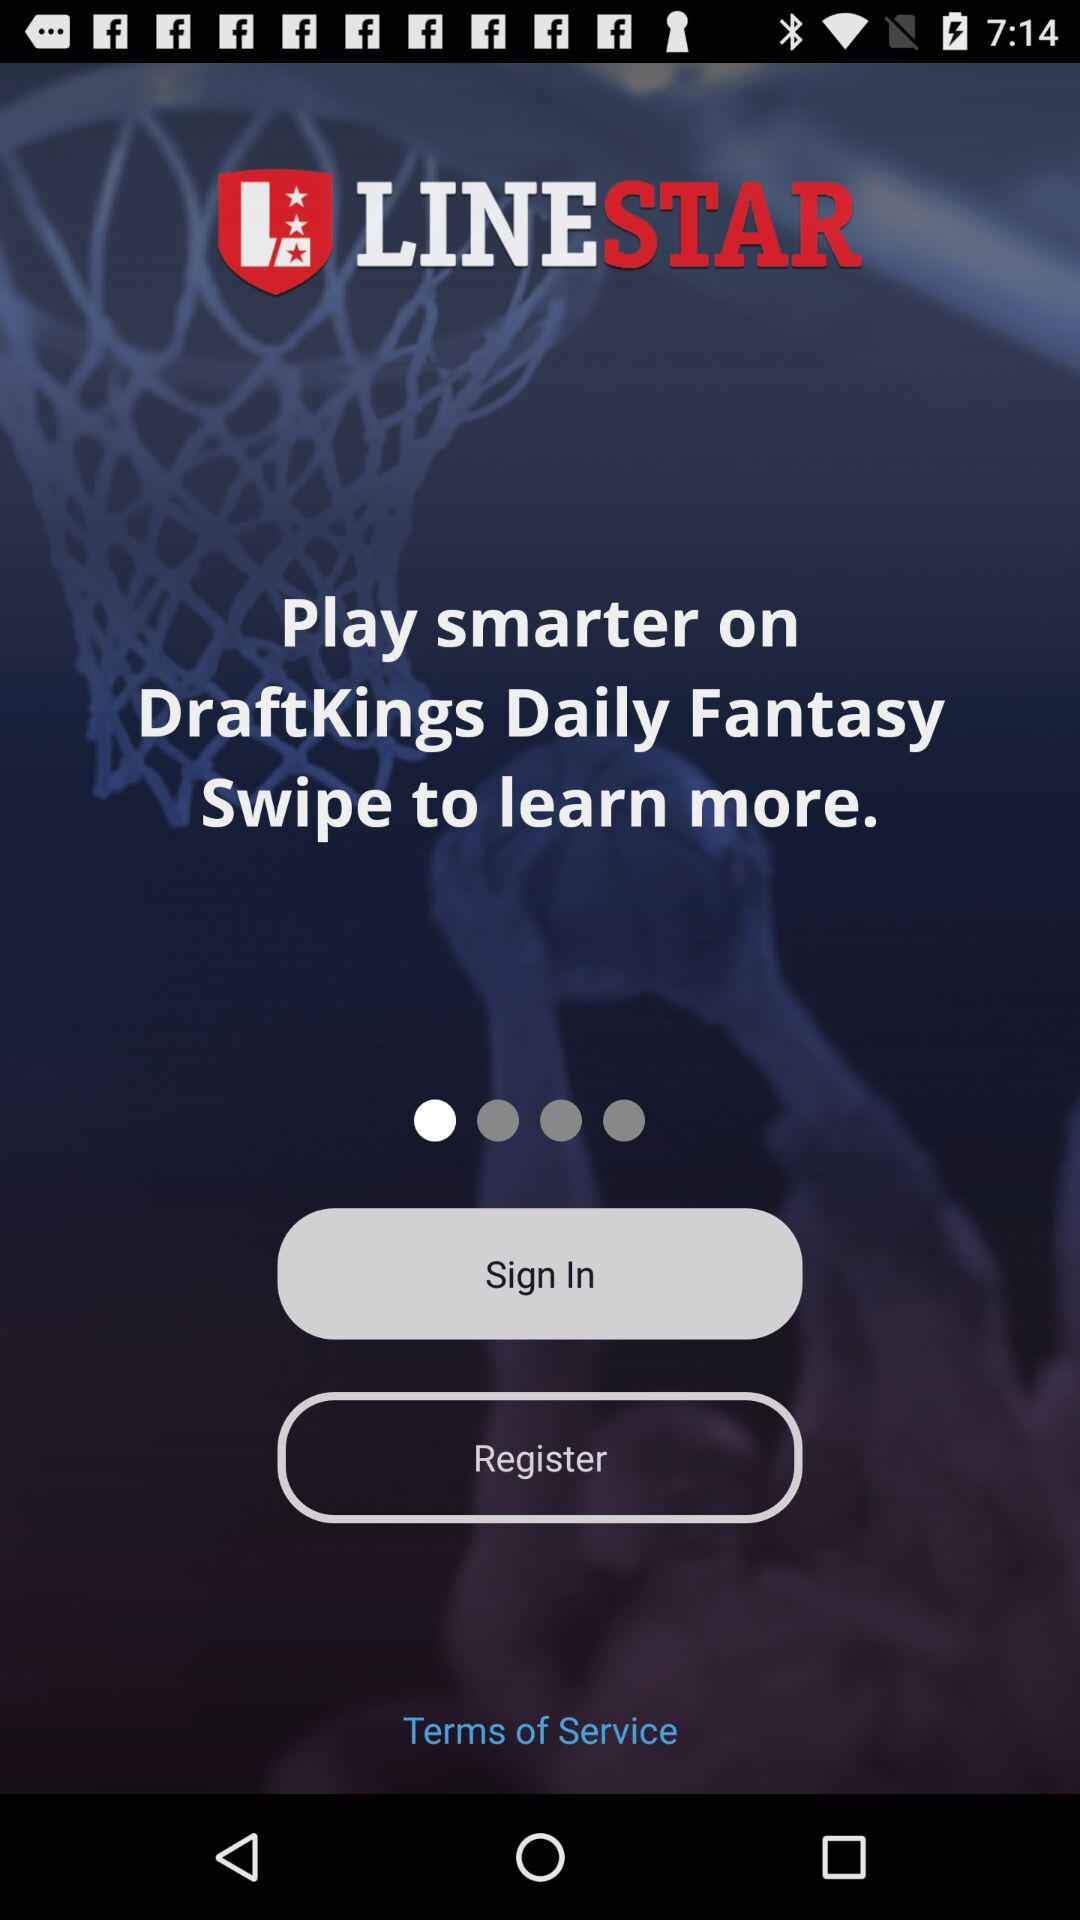What is the name of the application? The application name is "LINESTAR". 